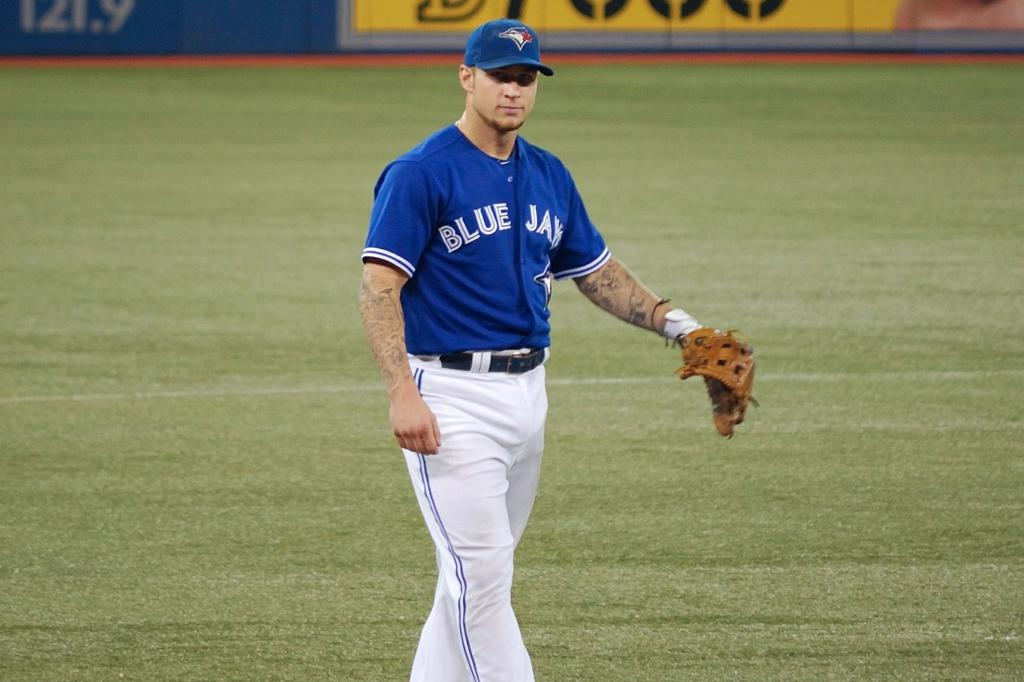<image>
Present a compact description of the photo's key features. Baseball player with white pant and a blue jersey that has Blue Jay printed on it. 